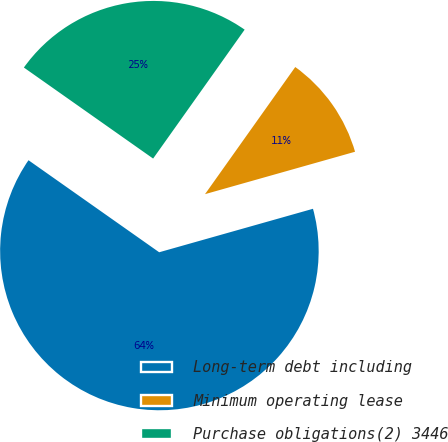Convert chart. <chart><loc_0><loc_0><loc_500><loc_500><pie_chart><fcel>Long-term debt including<fcel>Minimum operating lease<fcel>Purchase obligations(2) 3446<nl><fcel>64.15%<fcel>10.79%<fcel>25.06%<nl></chart> 